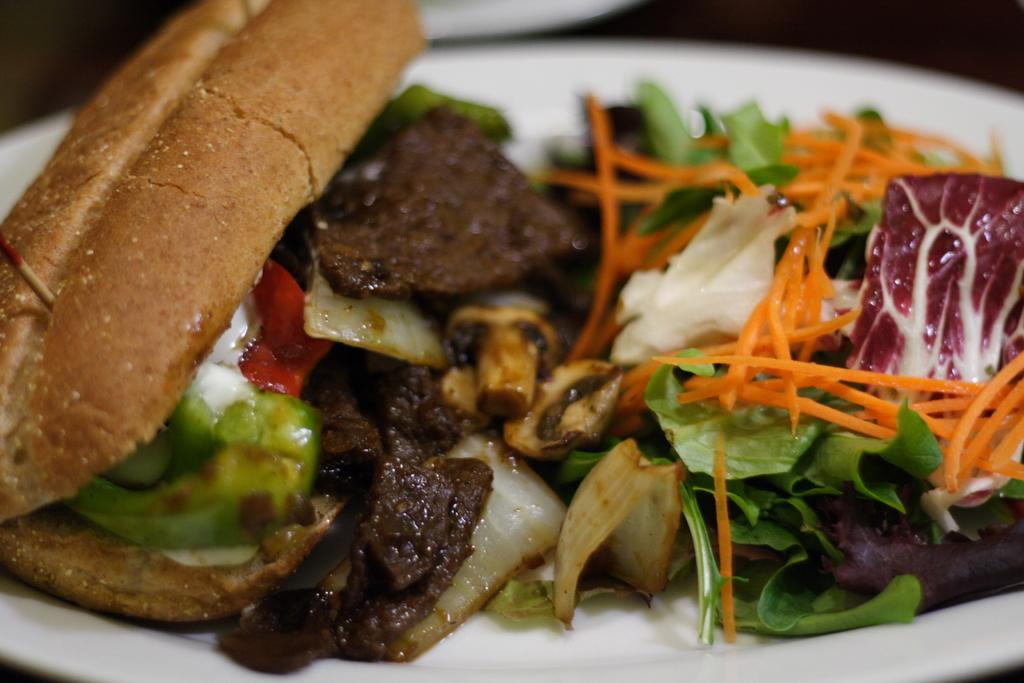What type of food is the main subject of the image? There is a sandwich in the image. What ingredients can be seen in the sandwich? There is meat and vegetables in the image. How are the sandwich ingredients arranged in the image? All the items are placed on a plate. How many eggs are visible in the image? There are no eggs present in the image. What does the mom say about the sandwich in the image? There is no mom or dialogue present in the image. 